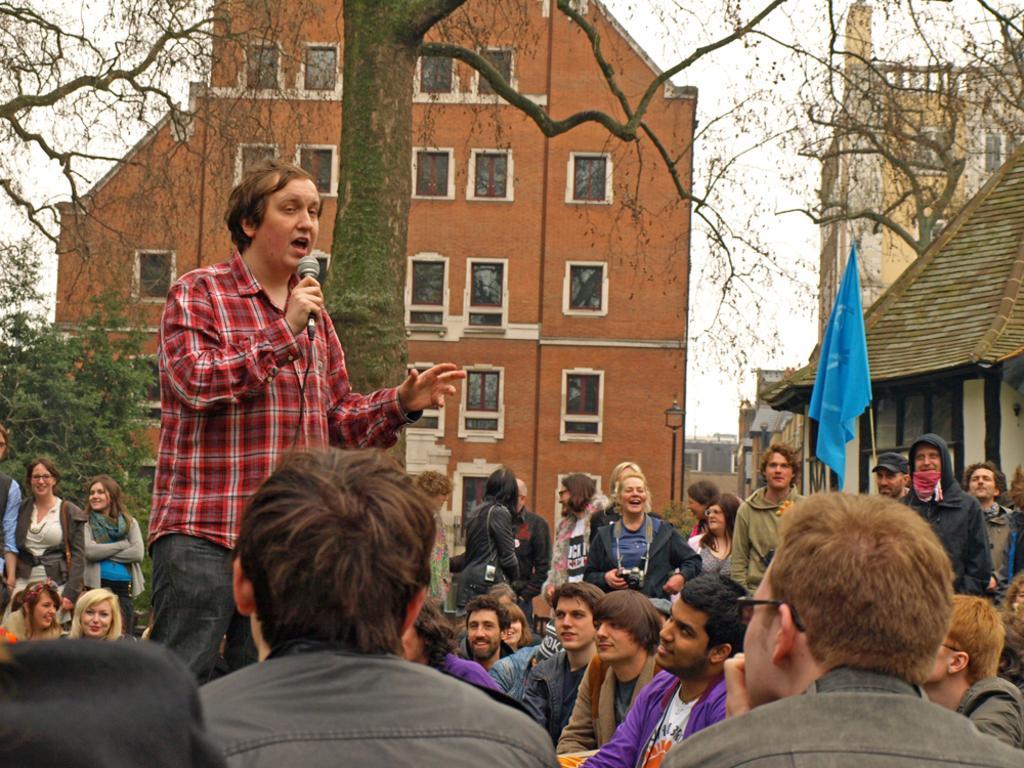In one or two sentences, can you explain what this image depicts? In the foreground of the image we can see some people are sitting. In the middle of the image we can see a person is standing and holding a mike in his hand and saying something. We can also see some people are standing. A flag and a building is there. On the top of the image we can see a building and trees. 